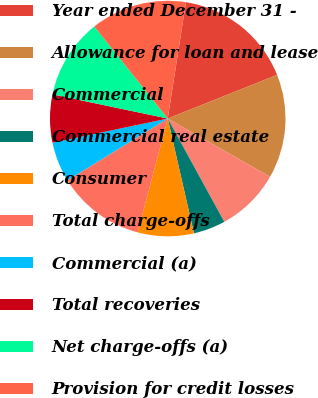Convert chart to OTSL. <chart><loc_0><loc_0><loc_500><loc_500><pie_chart><fcel>Year ended December 31 -<fcel>Allowance for loan and lease<fcel>Commercial<fcel>Commercial real estate<fcel>Consumer<fcel>Total charge-offs<fcel>Commercial (a)<fcel>Total recoveries<fcel>Net charge-offs (a)<fcel>Provision for credit losses<nl><fcel>16.48%<fcel>14.28%<fcel>8.79%<fcel>4.4%<fcel>7.69%<fcel>12.09%<fcel>5.5%<fcel>6.59%<fcel>10.99%<fcel>13.19%<nl></chart> 